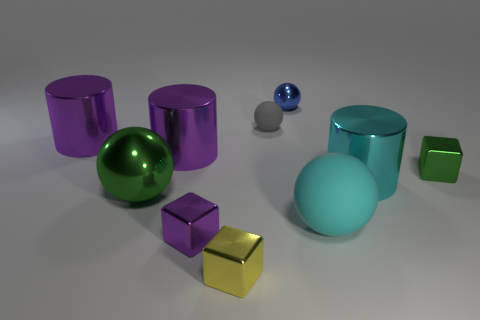Subtract all cyan balls. How many balls are left? 3 Subtract all purple cylinders. How many cylinders are left? 1 Subtract all blocks. How many objects are left? 7 Subtract all red cubes. How many purple cylinders are left? 2 Subtract 1 cylinders. How many cylinders are left? 2 Add 5 large cylinders. How many large cylinders are left? 8 Add 2 big purple blocks. How many big purple blocks exist? 2 Subtract 0 brown spheres. How many objects are left? 10 Subtract all brown blocks. Subtract all gray cylinders. How many blocks are left? 3 Subtract all tiny shiny balls. Subtract all tiny green cubes. How many objects are left? 8 